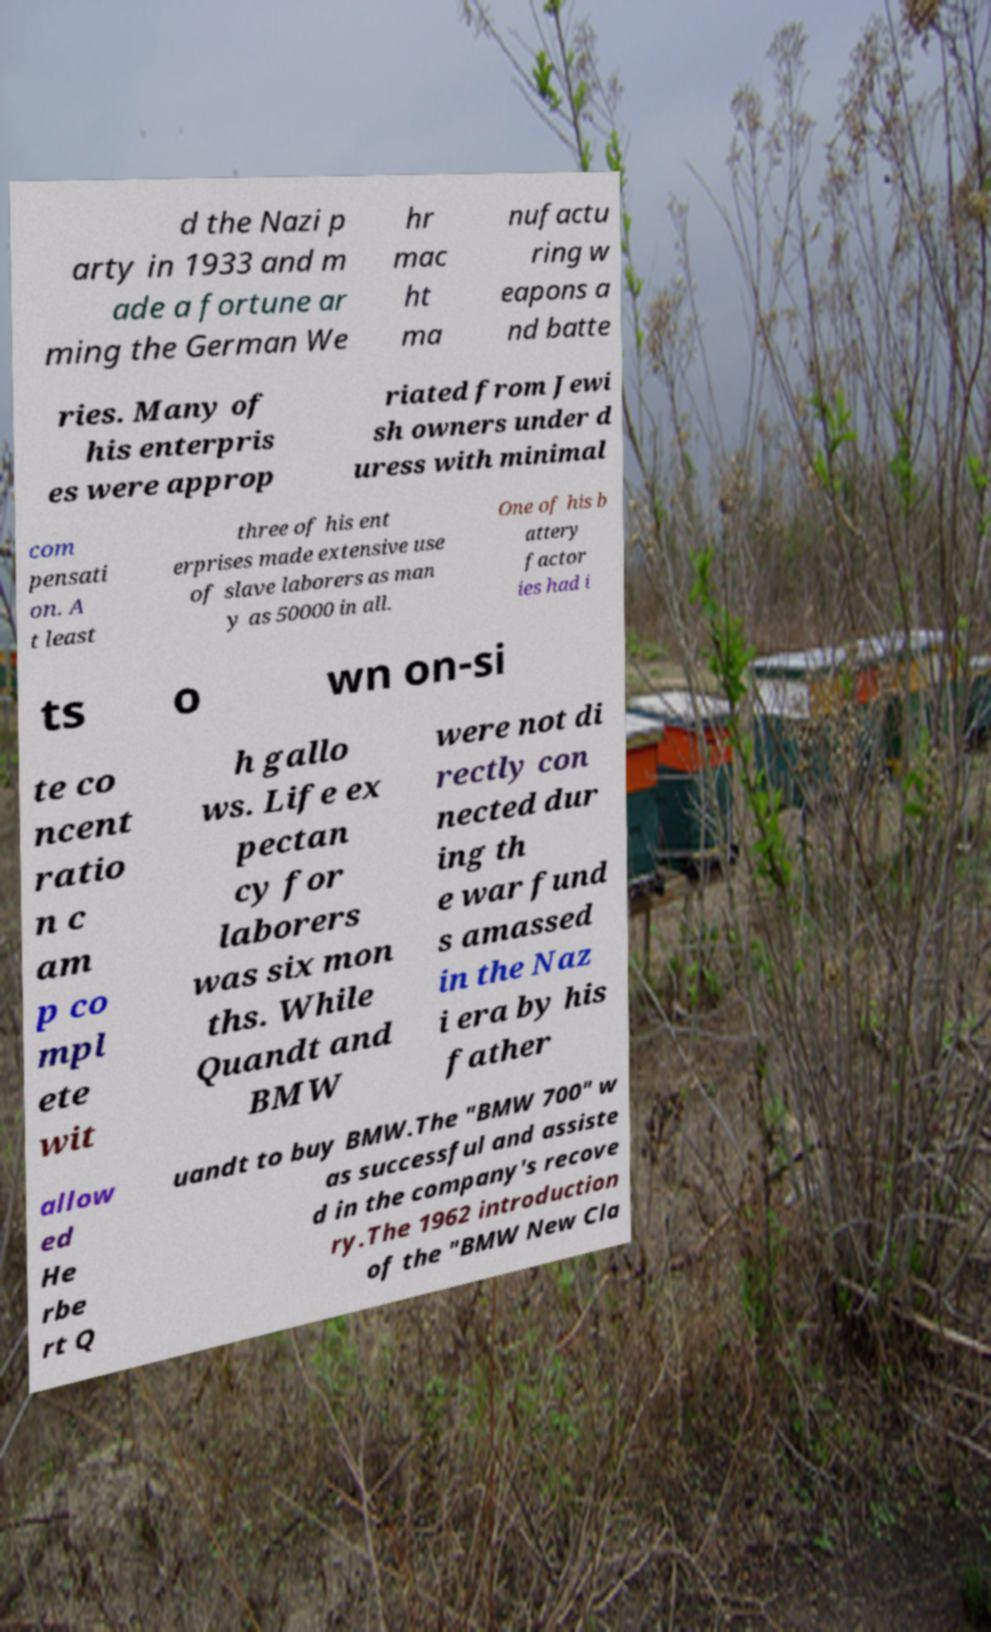For documentation purposes, I need the text within this image transcribed. Could you provide that? d the Nazi p arty in 1933 and m ade a fortune ar ming the German We hr mac ht ma nufactu ring w eapons a nd batte ries. Many of his enterpris es were approp riated from Jewi sh owners under d uress with minimal com pensati on. A t least three of his ent erprises made extensive use of slave laborers as man y as 50000 in all. One of his b attery factor ies had i ts o wn on-si te co ncent ratio n c am p co mpl ete wit h gallo ws. Life ex pectan cy for laborers was six mon ths. While Quandt and BMW were not di rectly con nected dur ing th e war fund s amassed in the Naz i era by his father allow ed He rbe rt Q uandt to buy BMW.The "BMW 700" w as successful and assiste d in the company's recove ry.The 1962 introduction of the "BMW New Cla 